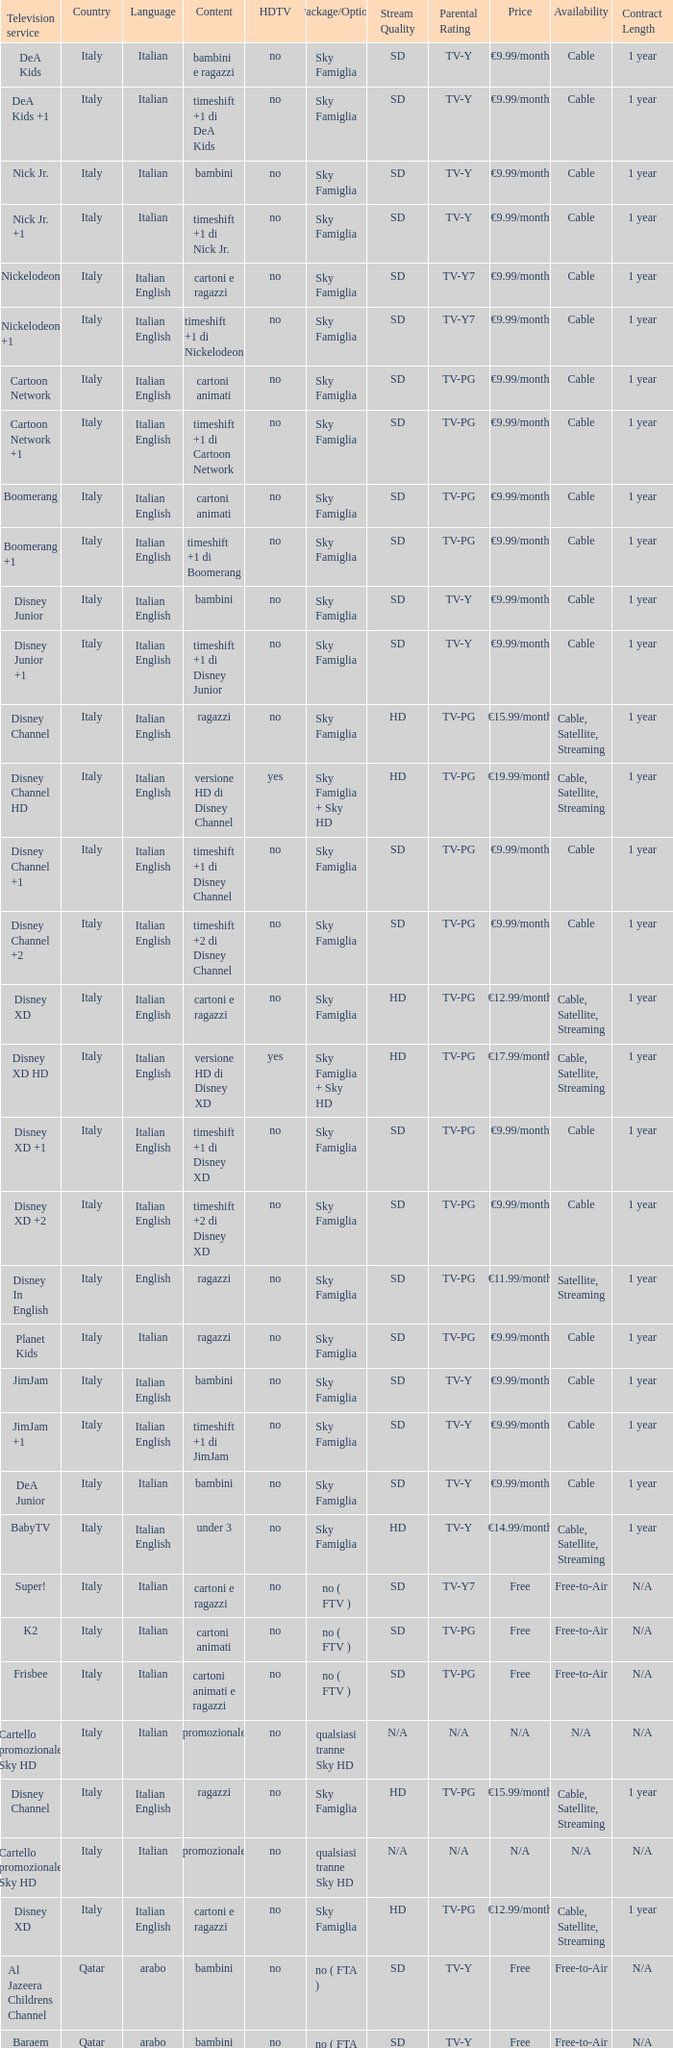What is the HDTV when the Package/Option is sky famiglia, and a Television service of boomerang +1? No. 